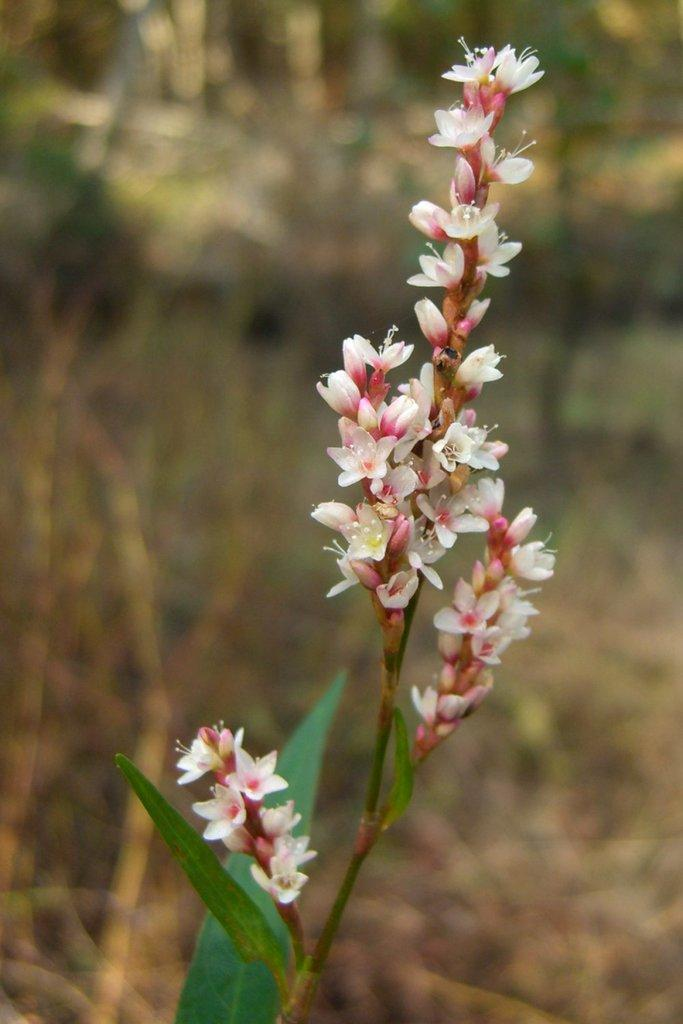What type of flora can be seen in the image? There are flowers and leaves in the image. Are there any plants visible in the background? Yes, there are plants in the background of the image. How would you describe the appearance of the background? The background appears blurry. What is the title of the journey depicted in the image? There is no journey depicted in the image, as it features flowers, leaves, and plants. 